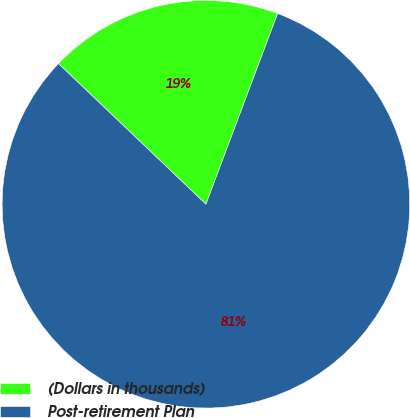Convert chart. <chart><loc_0><loc_0><loc_500><loc_500><pie_chart><fcel>(Dollars in thousands)<fcel>Post-retirement Plan<nl><fcel>18.6%<fcel>81.4%<nl></chart> 